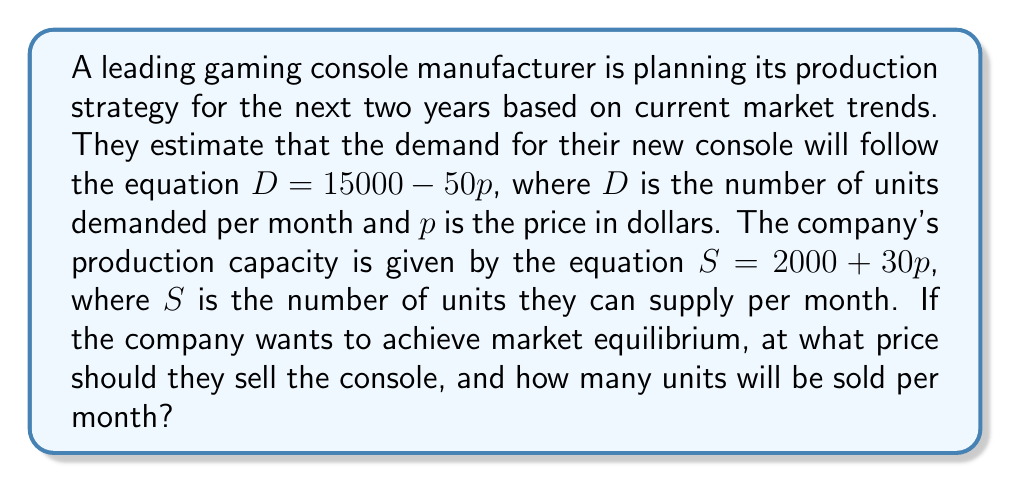Can you solve this math problem? To solve this problem, we need to find the point where supply equals demand, which is the market equilibrium. We can do this by setting up a system of equations:

1) Demand equation: $D = 15000 - 50p$
2) Supply equation: $S = 2000 + 30p$
3) At equilibrium: $D = S$

Let's solve this step-by-step:

1) Set the equations equal to each other:
   $15000 - 50p = 2000 + 30p$

2) Simplify by combining like terms:
   $13000 = 80p$

3) Solve for $p$:
   $p = 13000 / 80 = 162.5$

4) Now that we know the equilibrium price, we can substitute this back into either the demand or supply equation to find the quantity. Let's use the demand equation:

   $D = 15000 - 50(162.5)$
   $D = 15000 - 8125 = 6875$

Therefore, the equilibrium price is $162.5, and the equilibrium quantity is 6875 units per month.

This solution provides valuable insights for a technology trend analyst in the gaming industry. It shows how pricing affects both demand and production capacity, and helps predict the optimal price point and production volume for maximizing market efficiency.
Answer: The company should sell the console at $$162.50, and 6,875 units will be sold per month at this price. 